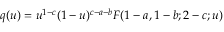<formula> <loc_0><loc_0><loc_500><loc_500>q ( u ) = u ^ { 1 - c } ( 1 - u ) ^ { c - a - b } F ( 1 - a , 1 - b ; 2 - c ; u )</formula> 